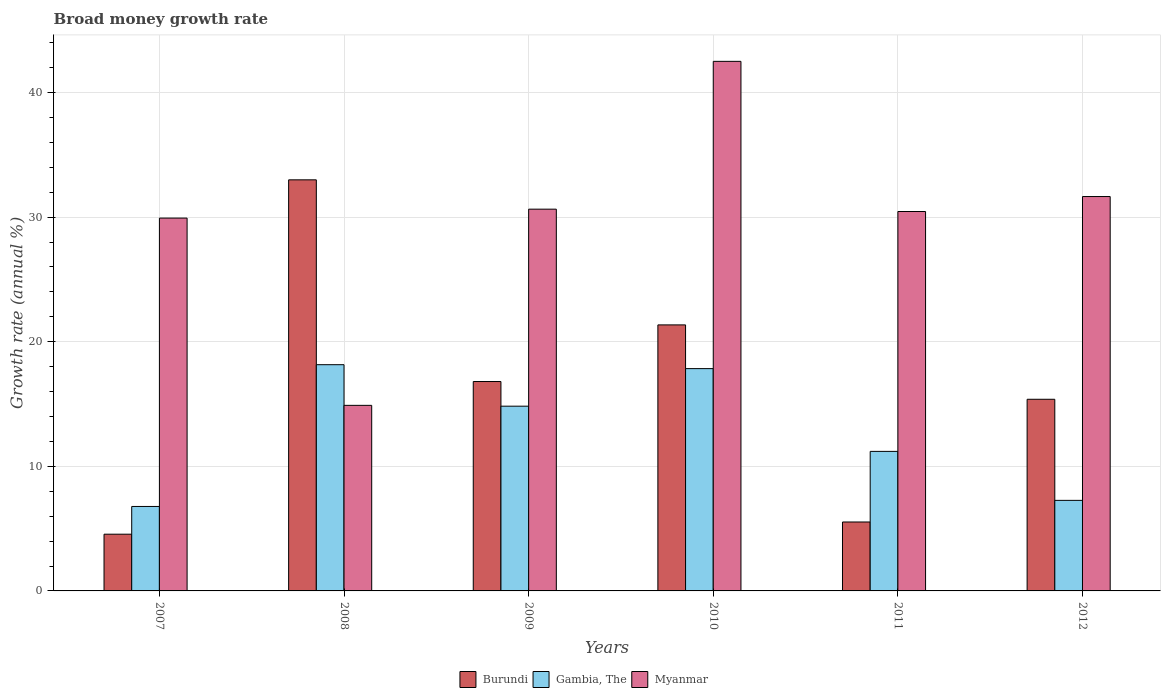Are the number of bars per tick equal to the number of legend labels?
Provide a short and direct response. Yes. Are the number of bars on each tick of the X-axis equal?
Your answer should be very brief. Yes. How many bars are there on the 1st tick from the left?
Your response must be concise. 3. How many bars are there on the 3rd tick from the right?
Provide a short and direct response. 3. What is the label of the 5th group of bars from the left?
Your response must be concise. 2011. What is the growth rate in Myanmar in 2007?
Your answer should be compact. 29.92. Across all years, what is the maximum growth rate in Gambia, The?
Offer a very short reply. 18.16. Across all years, what is the minimum growth rate in Gambia, The?
Your answer should be very brief. 6.78. What is the total growth rate in Gambia, The in the graph?
Ensure brevity in your answer.  76.07. What is the difference between the growth rate in Gambia, The in 2008 and that in 2011?
Offer a very short reply. 6.96. What is the difference between the growth rate in Burundi in 2008 and the growth rate in Gambia, The in 2010?
Offer a very short reply. 15.15. What is the average growth rate in Gambia, The per year?
Give a very brief answer. 12.68. In the year 2009, what is the difference between the growth rate in Myanmar and growth rate in Gambia, The?
Your answer should be compact. 15.81. In how many years, is the growth rate in Gambia, The greater than 28 %?
Your response must be concise. 0. What is the ratio of the growth rate in Myanmar in 2008 to that in 2010?
Make the answer very short. 0.35. Is the growth rate in Myanmar in 2011 less than that in 2012?
Keep it short and to the point. Yes. What is the difference between the highest and the second highest growth rate in Myanmar?
Give a very brief answer. 10.85. What is the difference between the highest and the lowest growth rate in Gambia, The?
Your answer should be very brief. 11.38. In how many years, is the growth rate in Gambia, The greater than the average growth rate in Gambia, The taken over all years?
Your answer should be very brief. 3. What does the 3rd bar from the left in 2007 represents?
Make the answer very short. Myanmar. What does the 1st bar from the right in 2010 represents?
Give a very brief answer. Myanmar. How many bars are there?
Provide a succinct answer. 18. Are all the bars in the graph horizontal?
Ensure brevity in your answer.  No. Does the graph contain grids?
Offer a terse response. Yes. How are the legend labels stacked?
Offer a very short reply. Horizontal. What is the title of the graph?
Your answer should be compact. Broad money growth rate. Does "Lesotho" appear as one of the legend labels in the graph?
Make the answer very short. No. What is the label or title of the Y-axis?
Keep it short and to the point. Growth rate (annual %). What is the Growth rate (annual %) of Burundi in 2007?
Provide a succinct answer. 4.55. What is the Growth rate (annual %) of Gambia, The in 2007?
Make the answer very short. 6.78. What is the Growth rate (annual %) in Myanmar in 2007?
Your answer should be compact. 29.92. What is the Growth rate (annual %) in Burundi in 2008?
Offer a terse response. 32.99. What is the Growth rate (annual %) in Gambia, The in 2008?
Give a very brief answer. 18.16. What is the Growth rate (annual %) in Myanmar in 2008?
Provide a succinct answer. 14.89. What is the Growth rate (annual %) of Burundi in 2009?
Your response must be concise. 16.81. What is the Growth rate (annual %) of Gambia, The in 2009?
Make the answer very short. 14.83. What is the Growth rate (annual %) in Myanmar in 2009?
Provide a short and direct response. 30.64. What is the Growth rate (annual %) in Burundi in 2010?
Offer a terse response. 21.35. What is the Growth rate (annual %) of Gambia, The in 2010?
Keep it short and to the point. 17.84. What is the Growth rate (annual %) in Myanmar in 2010?
Ensure brevity in your answer.  42.5. What is the Growth rate (annual %) in Burundi in 2011?
Provide a succinct answer. 5.53. What is the Growth rate (annual %) of Gambia, The in 2011?
Your answer should be compact. 11.2. What is the Growth rate (annual %) of Myanmar in 2011?
Your answer should be very brief. 30.45. What is the Growth rate (annual %) in Burundi in 2012?
Offer a terse response. 15.38. What is the Growth rate (annual %) of Gambia, The in 2012?
Your answer should be very brief. 7.27. What is the Growth rate (annual %) of Myanmar in 2012?
Your answer should be compact. 31.65. Across all years, what is the maximum Growth rate (annual %) in Burundi?
Make the answer very short. 32.99. Across all years, what is the maximum Growth rate (annual %) of Gambia, The?
Your answer should be compact. 18.16. Across all years, what is the maximum Growth rate (annual %) in Myanmar?
Ensure brevity in your answer.  42.5. Across all years, what is the minimum Growth rate (annual %) of Burundi?
Provide a short and direct response. 4.55. Across all years, what is the minimum Growth rate (annual %) in Gambia, The?
Provide a short and direct response. 6.78. Across all years, what is the minimum Growth rate (annual %) in Myanmar?
Keep it short and to the point. 14.89. What is the total Growth rate (annual %) in Burundi in the graph?
Give a very brief answer. 96.61. What is the total Growth rate (annual %) in Gambia, The in the graph?
Make the answer very short. 76.07. What is the total Growth rate (annual %) in Myanmar in the graph?
Keep it short and to the point. 180.05. What is the difference between the Growth rate (annual %) of Burundi in 2007 and that in 2008?
Offer a very short reply. -28.44. What is the difference between the Growth rate (annual %) of Gambia, The in 2007 and that in 2008?
Ensure brevity in your answer.  -11.38. What is the difference between the Growth rate (annual %) in Myanmar in 2007 and that in 2008?
Keep it short and to the point. 15.03. What is the difference between the Growth rate (annual %) in Burundi in 2007 and that in 2009?
Keep it short and to the point. -12.25. What is the difference between the Growth rate (annual %) of Gambia, The in 2007 and that in 2009?
Provide a succinct answer. -8.05. What is the difference between the Growth rate (annual %) in Myanmar in 2007 and that in 2009?
Make the answer very short. -0.72. What is the difference between the Growth rate (annual %) of Burundi in 2007 and that in 2010?
Provide a short and direct response. -16.8. What is the difference between the Growth rate (annual %) in Gambia, The in 2007 and that in 2010?
Make the answer very short. -11.06. What is the difference between the Growth rate (annual %) in Myanmar in 2007 and that in 2010?
Offer a terse response. -12.58. What is the difference between the Growth rate (annual %) of Burundi in 2007 and that in 2011?
Make the answer very short. -0.98. What is the difference between the Growth rate (annual %) in Gambia, The in 2007 and that in 2011?
Your answer should be very brief. -4.42. What is the difference between the Growth rate (annual %) in Myanmar in 2007 and that in 2011?
Your answer should be compact. -0.53. What is the difference between the Growth rate (annual %) of Burundi in 2007 and that in 2012?
Your response must be concise. -10.83. What is the difference between the Growth rate (annual %) of Gambia, The in 2007 and that in 2012?
Make the answer very short. -0.49. What is the difference between the Growth rate (annual %) of Myanmar in 2007 and that in 2012?
Provide a succinct answer. -1.73. What is the difference between the Growth rate (annual %) of Burundi in 2008 and that in 2009?
Offer a very short reply. 16.19. What is the difference between the Growth rate (annual %) in Gambia, The in 2008 and that in 2009?
Keep it short and to the point. 3.33. What is the difference between the Growth rate (annual %) in Myanmar in 2008 and that in 2009?
Provide a succinct answer. -15.75. What is the difference between the Growth rate (annual %) of Burundi in 2008 and that in 2010?
Ensure brevity in your answer.  11.64. What is the difference between the Growth rate (annual %) in Gambia, The in 2008 and that in 2010?
Your answer should be compact. 0.32. What is the difference between the Growth rate (annual %) in Myanmar in 2008 and that in 2010?
Provide a succinct answer. -27.61. What is the difference between the Growth rate (annual %) in Burundi in 2008 and that in 2011?
Your answer should be compact. 27.46. What is the difference between the Growth rate (annual %) in Gambia, The in 2008 and that in 2011?
Your answer should be very brief. 6.96. What is the difference between the Growth rate (annual %) in Myanmar in 2008 and that in 2011?
Provide a short and direct response. -15.56. What is the difference between the Growth rate (annual %) in Burundi in 2008 and that in 2012?
Your answer should be compact. 17.61. What is the difference between the Growth rate (annual %) in Gambia, The in 2008 and that in 2012?
Your answer should be compact. 10.89. What is the difference between the Growth rate (annual %) in Myanmar in 2008 and that in 2012?
Your answer should be compact. -16.76. What is the difference between the Growth rate (annual %) in Burundi in 2009 and that in 2010?
Keep it short and to the point. -4.54. What is the difference between the Growth rate (annual %) of Gambia, The in 2009 and that in 2010?
Your response must be concise. -3.01. What is the difference between the Growth rate (annual %) in Myanmar in 2009 and that in 2010?
Your answer should be compact. -11.86. What is the difference between the Growth rate (annual %) in Burundi in 2009 and that in 2011?
Provide a short and direct response. 11.27. What is the difference between the Growth rate (annual %) of Gambia, The in 2009 and that in 2011?
Offer a very short reply. 3.63. What is the difference between the Growth rate (annual %) in Myanmar in 2009 and that in 2011?
Your response must be concise. 0.19. What is the difference between the Growth rate (annual %) in Burundi in 2009 and that in 2012?
Give a very brief answer. 1.42. What is the difference between the Growth rate (annual %) in Gambia, The in 2009 and that in 2012?
Provide a short and direct response. 7.56. What is the difference between the Growth rate (annual %) in Myanmar in 2009 and that in 2012?
Your response must be concise. -1.01. What is the difference between the Growth rate (annual %) in Burundi in 2010 and that in 2011?
Offer a terse response. 15.82. What is the difference between the Growth rate (annual %) of Gambia, The in 2010 and that in 2011?
Offer a very short reply. 6.64. What is the difference between the Growth rate (annual %) of Myanmar in 2010 and that in 2011?
Provide a succinct answer. 12.05. What is the difference between the Growth rate (annual %) in Burundi in 2010 and that in 2012?
Offer a very short reply. 5.97. What is the difference between the Growth rate (annual %) of Gambia, The in 2010 and that in 2012?
Your answer should be compact. 10.57. What is the difference between the Growth rate (annual %) of Myanmar in 2010 and that in 2012?
Give a very brief answer. 10.85. What is the difference between the Growth rate (annual %) of Burundi in 2011 and that in 2012?
Your answer should be compact. -9.85. What is the difference between the Growth rate (annual %) of Gambia, The in 2011 and that in 2012?
Keep it short and to the point. 3.93. What is the difference between the Growth rate (annual %) of Myanmar in 2011 and that in 2012?
Offer a very short reply. -1.2. What is the difference between the Growth rate (annual %) of Burundi in 2007 and the Growth rate (annual %) of Gambia, The in 2008?
Ensure brevity in your answer.  -13.6. What is the difference between the Growth rate (annual %) of Burundi in 2007 and the Growth rate (annual %) of Myanmar in 2008?
Provide a short and direct response. -10.34. What is the difference between the Growth rate (annual %) in Gambia, The in 2007 and the Growth rate (annual %) in Myanmar in 2008?
Ensure brevity in your answer.  -8.11. What is the difference between the Growth rate (annual %) in Burundi in 2007 and the Growth rate (annual %) in Gambia, The in 2009?
Give a very brief answer. -10.27. What is the difference between the Growth rate (annual %) of Burundi in 2007 and the Growth rate (annual %) of Myanmar in 2009?
Provide a short and direct response. -26.08. What is the difference between the Growth rate (annual %) in Gambia, The in 2007 and the Growth rate (annual %) in Myanmar in 2009?
Make the answer very short. -23.86. What is the difference between the Growth rate (annual %) in Burundi in 2007 and the Growth rate (annual %) in Gambia, The in 2010?
Give a very brief answer. -13.29. What is the difference between the Growth rate (annual %) of Burundi in 2007 and the Growth rate (annual %) of Myanmar in 2010?
Provide a succinct answer. -37.95. What is the difference between the Growth rate (annual %) of Gambia, The in 2007 and the Growth rate (annual %) of Myanmar in 2010?
Your answer should be compact. -35.72. What is the difference between the Growth rate (annual %) of Burundi in 2007 and the Growth rate (annual %) of Gambia, The in 2011?
Offer a very short reply. -6.65. What is the difference between the Growth rate (annual %) of Burundi in 2007 and the Growth rate (annual %) of Myanmar in 2011?
Give a very brief answer. -25.9. What is the difference between the Growth rate (annual %) in Gambia, The in 2007 and the Growth rate (annual %) in Myanmar in 2011?
Give a very brief answer. -23.67. What is the difference between the Growth rate (annual %) of Burundi in 2007 and the Growth rate (annual %) of Gambia, The in 2012?
Your answer should be compact. -2.71. What is the difference between the Growth rate (annual %) in Burundi in 2007 and the Growth rate (annual %) in Myanmar in 2012?
Offer a terse response. -27.1. What is the difference between the Growth rate (annual %) of Gambia, The in 2007 and the Growth rate (annual %) of Myanmar in 2012?
Your response must be concise. -24.87. What is the difference between the Growth rate (annual %) of Burundi in 2008 and the Growth rate (annual %) of Gambia, The in 2009?
Give a very brief answer. 18.17. What is the difference between the Growth rate (annual %) in Burundi in 2008 and the Growth rate (annual %) in Myanmar in 2009?
Ensure brevity in your answer.  2.35. What is the difference between the Growth rate (annual %) of Gambia, The in 2008 and the Growth rate (annual %) of Myanmar in 2009?
Your answer should be compact. -12.48. What is the difference between the Growth rate (annual %) of Burundi in 2008 and the Growth rate (annual %) of Gambia, The in 2010?
Your answer should be very brief. 15.15. What is the difference between the Growth rate (annual %) in Burundi in 2008 and the Growth rate (annual %) in Myanmar in 2010?
Offer a very short reply. -9.51. What is the difference between the Growth rate (annual %) of Gambia, The in 2008 and the Growth rate (annual %) of Myanmar in 2010?
Provide a short and direct response. -24.34. What is the difference between the Growth rate (annual %) in Burundi in 2008 and the Growth rate (annual %) in Gambia, The in 2011?
Keep it short and to the point. 21.79. What is the difference between the Growth rate (annual %) in Burundi in 2008 and the Growth rate (annual %) in Myanmar in 2011?
Give a very brief answer. 2.54. What is the difference between the Growth rate (annual %) in Gambia, The in 2008 and the Growth rate (annual %) in Myanmar in 2011?
Offer a terse response. -12.29. What is the difference between the Growth rate (annual %) in Burundi in 2008 and the Growth rate (annual %) in Gambia, The in 2012?
Give a very brief answer. 25.72. What is the difference between the Growth rate (annual %) of Burundi in 2008 and the Growth rate (annual %) of Myanmar in 2012?
Ensure brevity in your answer.  1.34. What is the difference between the Growth rate (annual %) of Gambia, The in 2008 and the Growth rate (annual %) of Myanmar in 2012?
Ensure brevity in your answer.  -13.49. What is the difference between the Growth rate (annual %) of Burundi in 2009 and the Growth rate (annual %) of Gambia, The in 2010?
Offer a very short reply. -1.04. What is the difference between the Growth rate (annual %) in Burundi in 2009 and the Growth rate (annual %) in Myanmar in 2010?
Provide a succinct answer. -25.69. What is the difference between the Growth rate (annual %) in Gambia, The in 2009 and the Growth rate (annual %) in Myanmar in 2010?
Make the answer very short. -27.67. What is the difference between the Growth rate (annual %) in Burundi in 2009 and the Growth rate (annual %) in Gambia, The in 2011?
Give a very brief answer. 5.61. What is the difference between the Growth rate (annual %) of Burundi in 2009 and the Growth rate (annual %) of Myanmar in 2011?
Provide a succinct answer. -13.64. What is the difference between the Growth rate (annual %) of Gambia, The in 2009 and the Growth rate (annual %) of Myanmar in 2011?
Make the answer very short. -15.62. What is the difference between the Growth rate (annual %) in Burundi in 2009 and the Growth rate (annual %) in Gambia, The in 2012?
Ensure brevity in your answer.  9.54. What is the difference between the Growth rate (annual %) of Burundi in 2009 and the Growth rate (annual %) of Myanmar in 2012?
Offer a terse response. -14.84. What is the difference between the Growth rate (annual %) in Gambia, The in 2009 and the Growth rate (annual %) in Myanmar in 2012?
Keep it short and to the point. -16.82. What is the difference between the Growth rate (annual %) in Burundi in 2010 and the Growth rate (annual %) in Gambia, The in 2011?
Provide a succinct answer. 10.15. What is the difference between the Growth rate (annual %) of Gambia, The in 2010 and the Growth rate (annual %) of Myanmar in 2011?
Your response must be concise. -12.61. What is the difference between the Growth rate (annual %) in Burundi in 2010 and the Growth rate (annual %) in Gambia, The in 2012?
Your answer should be very brief. 14.08. What is the difference between the Growth rate (annual %) of Burundi in 2010 and the Growth rate (annual %) of Myanmar in 2012?
Provide a short and direct response. -10.3. What is the difference between the Growth rate (annual %) in Gambia, The in 2010 and the Growth rate (annual %) in Myanmar in 2012?
Your answer should be compact. -13.81. What is the difference between the Growth rate (annual %) in Burundi in 2011 and the Growth rate (annual %) in Gambia, The in 2012?
Provide a short and direct response. -1.74. What is the difference between the Growth rate (annual %) in Burundi in 2011 and the Growth rate (annual %) in Myanmar in 2012?
Offer a terse response. -26.12. What is the difference between the Growth rate (annual %) of Gambia, The in 2011 and the Growth rate (annual %) of Myanmar in 2012?
Give a very brief answer. -20.45. What is the average Growth rate (annual %) in Burundi per year?
Keep it short and to the point. 16.1. What is the average Growth rate (annual %) of Gambia, The per year?
Give a very brief answer. 12.68. What is the average Growth rate (annual %) of Myanmar per year?
Your answer should be very brief. 30.01. In the year 2007, what is the difference between the Growth rate (annual %) in Burundi and Growth rate (annual %) in Gambia, The?
Provide a succinct answer. -2.23. In the year 2007, what is the difference between the Growth rate (annual %) in Burundi and Growth rate (annual %) in Myanmar?
Your answer should be very brief. -25.37. In the year 2007, what is the difference between the Growth rate (annual %) of Gambia, The and Growth rate (annual %) of Myanmar?
Keep it short and to the point. -23.14. In the year 2008, what is the difference between the Growth rate (annual %) of Burundi and Growth rate (annual %) of Gambia, The?
Your answer should be compact. 14.84. In the year 2008, what is the difference between the Growth rate (annual %) of Burundi and Growth rate (annual %) of Myanmar?
Your answer should be very brief. 18.1. In the year 2008, what is the difference between the Growth rate (annual %) of Gambia, The and Growth rate (annual %) of Myanmar?
Ensure brevity in your answer.  3.26. In the year 2009, what is the difference between the Growth rate (annual %) of Burundi and Growth rate (annual %) of Gambia, The?
Ensure brevity in your answer.  1.98. In the year 2009, what is the difference between the Growth rate (annual %) in Burundi and Growth rate (annual %) in Myanmar?
Offer a terse response. -13.83. In the year 2009, what is the difference between the Growth rate (annual %) in Gambia, The and Growth rate (annual %) in Myanmar?
Offer a terse response. -15.81. In the year 2010, what is the difference between the Growth rate (annual %) of Burundi and Growth rate (annual %) of Gambia, The?
Offer a terse response. 3.51. In the year 2010, what is the difference between the Growth rate (annual %) of Burundi and Growth rate (annual %) of Myanmar?
Your answer should be compact. -21.15. In the year 2010, what is the difference between the Growth rate (annual %) of Gambia, The and Growth rate (annual %) of Myanmar?
Offer a very short reply. -24.66. In the year 2011, what is the difference between the Growth rate (annual %) in Burundi and Growth rate (annual %) in Gambia, The?
Give a very brief answer. -5.67. In the year 2011, what is the difference between the Growth rate (annual %) in Burundi and Growth rate (annual %) in Myanmar?
Provide a succinct answer. -24.92. In the year 2011, what is the difference between the Growth rate (annual %) in Gambia, The and Growth rate (annual %) in Myanmar?
Provide a succinct answer. -19.25. In the year 2012, what is the difference between the Growth rate (annual %) in Burundi and Growth rate (annual %) in Gambia, The?
Give a very brief answer. 8.11. In the year 2012, what is the difference between the Growth rate (annual %) in Burundi and Growth rate (annual %) in Myanmar?
Provide a succinct answer. -16.27. In the year 2012, what is the difference between the Growth rate (annual %) of Gambia, The and Growth rate (annual %) of Myanmar?
Your answer should be compact. -24.38. What is the ratio of the Growth rate (annual %) in Burundi in 2007 to that in 2008?
Your answer should be compact. 0.14. What is the ratio of the Growth rate (annual %) in Gambia, The in 2007 to that in 2008?
Your answer should be very brief. 0.37. What is the ratio of the Growth rate (annual %) of Myanmar in 2007 to that in 2008?
Provide a succinct answer. 2.01. What is the ratio of the Growth rate (annual %) in Burundi in 2007 to that in 2009?
Ensure brevity in your answer.  0.27. What is the ratio of the Growth rate (annual %) in Gambia, The in 2007 to that in 2009?
Offer a very short reply. 0.46. What is the ratio of the Growth rate (annual %) of Myanmar in 2007 to that in 2009?
Your answer should be compact. 0.98. What is the ratio of the Growth rate (annual %) in Burundi in 2007 to that in 2010?
Provide a short and direct response. 0.21. What is the ratio of the Growth rate (annual %) of Gambia, The in 2007 to that in 2010?
Your answer should be compact. 0.38. What is the ratio of the Growth rate (annual %) in Myanmar in 2007 to that in 2010?
Offer a terse response. 0.7. What is the ratio of the Growth rate (annual %) in Burundi in 2007 to that in 2011?
Your answer should be compact. 0.82. What is the ratio of the Growth rate (annual %) of Gambia, The in 2007 to that in 2011?
Keep it short and to the point. 0.61. What is the ratio of the Growth rate (annual %) of Myanmar in 2007 to that in 2011?
Your answer should be very brief. 0.98. What is the ratio of the Growth rate (annual %) of Burundi in 2007 to that in 2012?
Provide a short and direct response. 0.3. What is the ratio of the Growth rate (annual %) of Gambia, The in 2007 to that in 2012?
Offer a terse response. 0.93. What is the ratio of the Growth rate (annual %) in Myanmar in 2007 to that in 2012?
Provide a succinct answer. 0.95. What is the ratio of the Growth rate (annual %) in Burundi in 2008 to that in 2009?
Provide a succinct answer. 1.96. What is the ratio of the Growth rate (annual %) in Gambia, The in 2008 to that in 2009?
Your answer should be very brief. 1.22. What is the ratio of the Growth rate (annual %) of Myanmar in 2008 to that in 2009?
Offer a terse response. 0.49. What is the ratio of the Growth rate (annual %) of Burundi in 2008 to that in 2010?
Offer a very short reply. 1.55. What is the ratio of the Growth rate (annual %) of Gambia, The in 2008 to that in 2010?
Provide a succinct answer. 1.02. What is the ratio of the Growth rate (annual %) in Myanmar in 2008 to that in 2010?
Offer a very short reply. 0.35. What is the ratio of the Growth rate (annual %) in Burundi in 2008 to that in 2011?
Your answer should be very brief. 5.96. What is the ratio of the Growth rate (annual %) of Gambia, The in 2008 to that in 2011?
Ensure brevity in your answer.  1.62. What is the ratio of the Growth rate (annual %) of Myanmar in 2008 to that in 2011?
Keep it short and to the point. 0.49. What is the ratio of the Growth rate (annual %) of Burundi in 2008 to that in 2012?
Provide a succinct answer. 2.15. What is the ratio of the Growth rate (annual %) in Gambia, The in 2008 to that in 2012?
Offer a terse response. 2.5. What is the ratio of the Growth rate (annual %) in Myanmar in 2008 to that in 2012?
Provide a succinct answer. 0.47. What is the ratio of the Growth rate (annual %) of Burundi in 2009 to that in 2010?
Make the answer very short. 0.79. What is the ratio of the Growth rate (annual %) in Gambia, The in 2009 to that in 2010?
Give a very brief answer. 0.83. What is the ratio of the Growth rate (annual %) in Myanmar in 2009 to that in 2010?
Keep it short and to the point. 0.72. What is the ratio of the Growth rate (annual %) of Burundi in 2009 to that in 2011?
Your response must be concise. 3.04. What is the ratio of the Growth rate (annual %) in Gambia, The in 2009 to that in 2011?
Provide a succinct answer. 1.32. What is the ratio of the Growth rate (annual %) in Myanmar in 2009 to that in 2011?
Keep it short and to the point. 1.01. What is the ratio of the Growth rate (annual %) in Burundi in 2009 to that in 2012?
Keep it short and to the point. 1.09. What is the ratio of the Growth rate (annual %) of Gambia, The in 2009 to that in 2012?
Make the answer very short. 2.04. What is the ratio of the Growth rate (annual %) in Burundi in 2010 to that in 2011?
Make the answer very short. 3.86. What is the ratio of the Growth rate (annual %) in Gambia, The in 2010 to that in 2011?
Offer a terse response. 1.59. What is the ratio of the Growth rate (annual %) in Myanmar in 2010 to that in 2011?
Ensure brevity in your answer.  1.4. What is the ratio of the Growth rate (annual %) in Burundi in 2010 to that in 2012?
Provide a short and direct response. 1.39. What is the ratio of the Growth rate (annual %) in Gambia, The in 2010 to that in 2012?
Make the answer very short. 2.45. What is the ratio of the Growth rate (annual %) in Myanmar in 2010 to that in 2012?
Ensure brevity in your answer.  1.34. What is the ratio of the Growth rate (annual %) in Burundi in 2011 to that in 2012?
Your answer should be very brief. 0.36. What is the ratio of the Growth rate (annual %) in Gambia, The in 2011 to that in 2012?
Give a very brief answer. 1.54. What is the ratio of the Growth rate (annual %) of Myanmar in 2011 to that in 2012?
Your response must be concise. 0.96. What is the difference between the highest and the second highest Growth rate (annual %) of Burundi?
Provide a short and direct response. 11.64. What is the difference between the highest and the second highest Growth rate (annual %) of Gambia, The?
Your answer should be very brief. 0.32. What is the difference between the highest and the second highest Growth rate (annual %) of Myanmar?
Ensure brevity in your answer.  10.85. What is the difference between the highest and the lowest Growth rate (annual %) in Burundi?
Provide a short and direct response. 28.44. What is the difference between the highest and the lowest Growth rate (annual %) in Gambia, The?
Make the answer very short. 11.38. What is the difference between the highest and the lowest Growth rate (annual %) of Myanmar?
Keep it short and to the point. 27.61. 